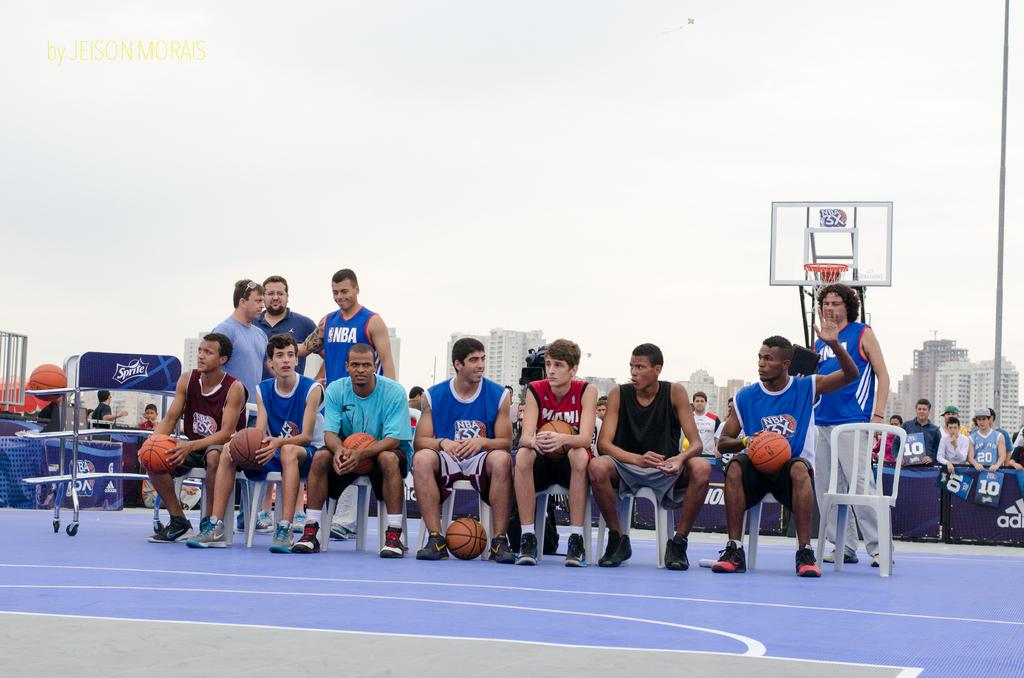<image>
Relay a brief, clear account of the picture shown. players sitting in chairs and others standing around, many wearing nba and nba3x shirts 